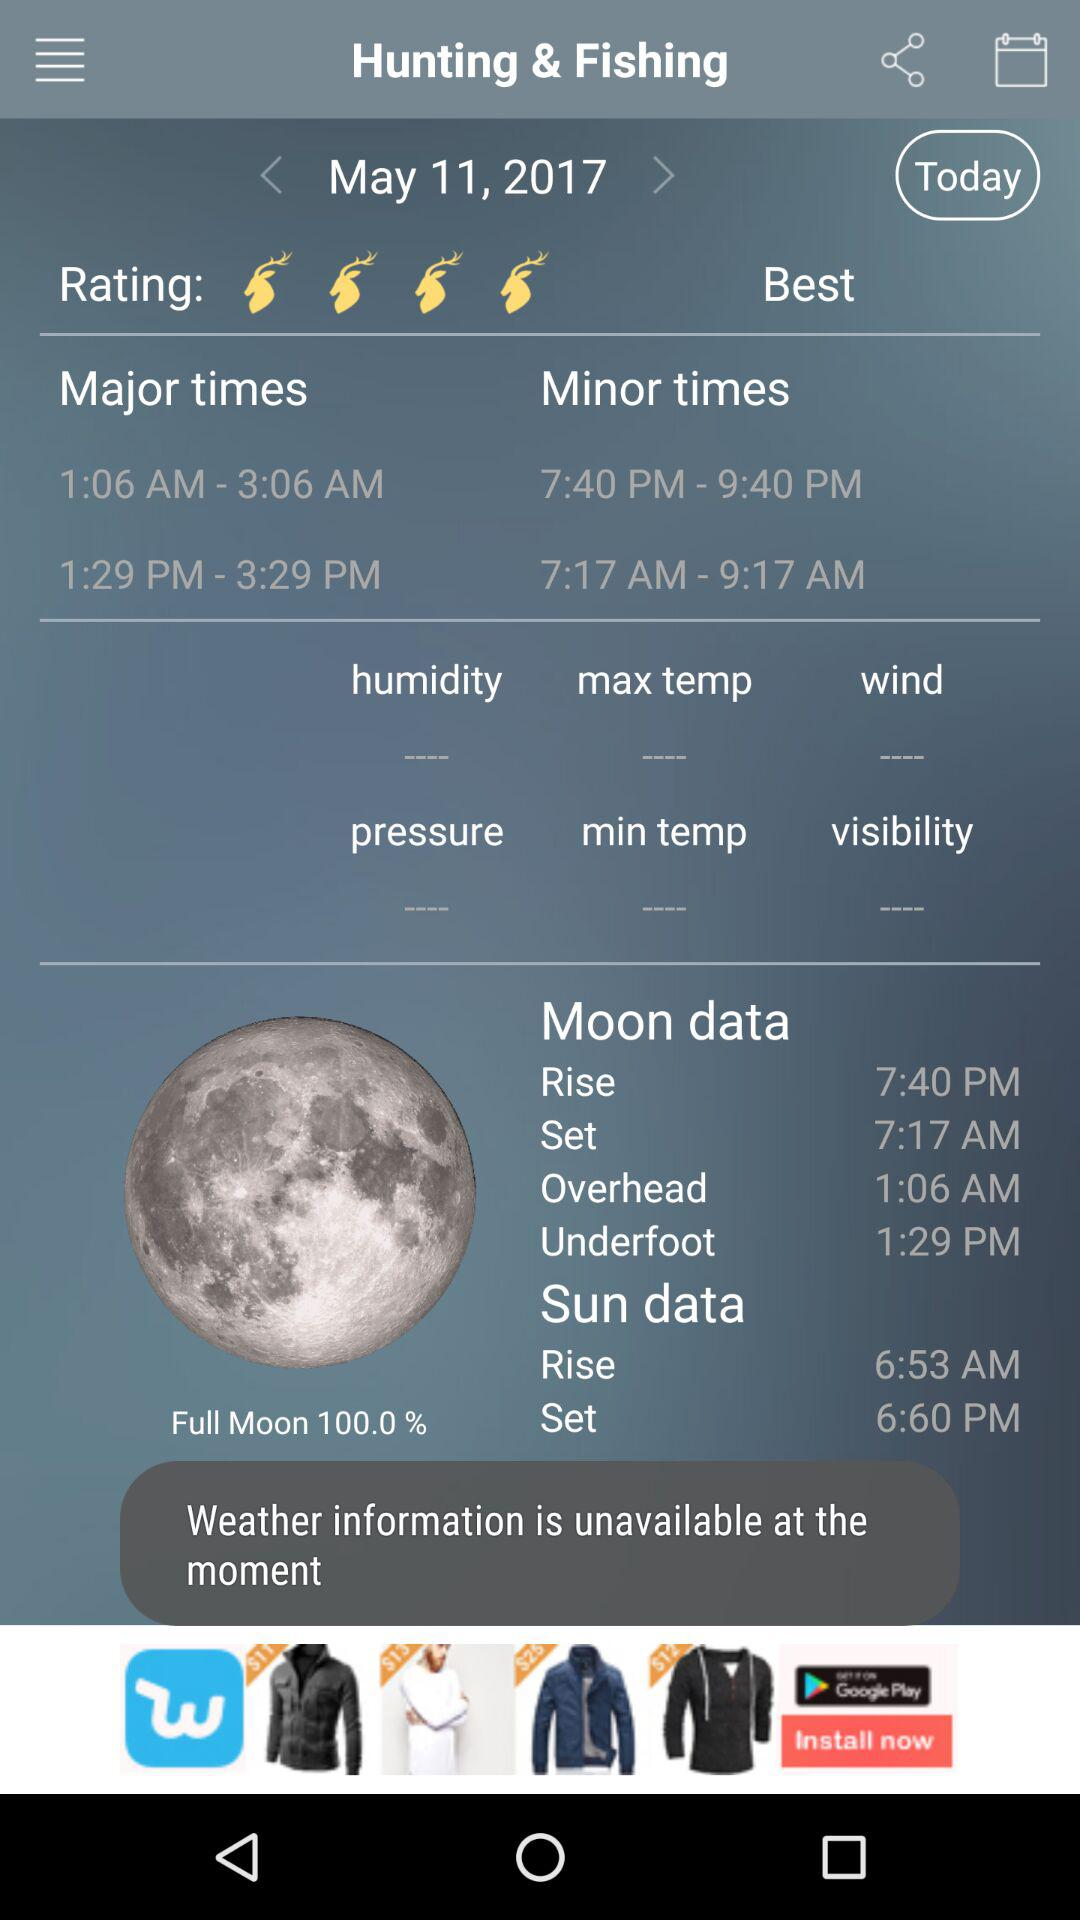Which timezone is the user in?
When the provided information is insufficient, respond with <no answer>. <no answer> 